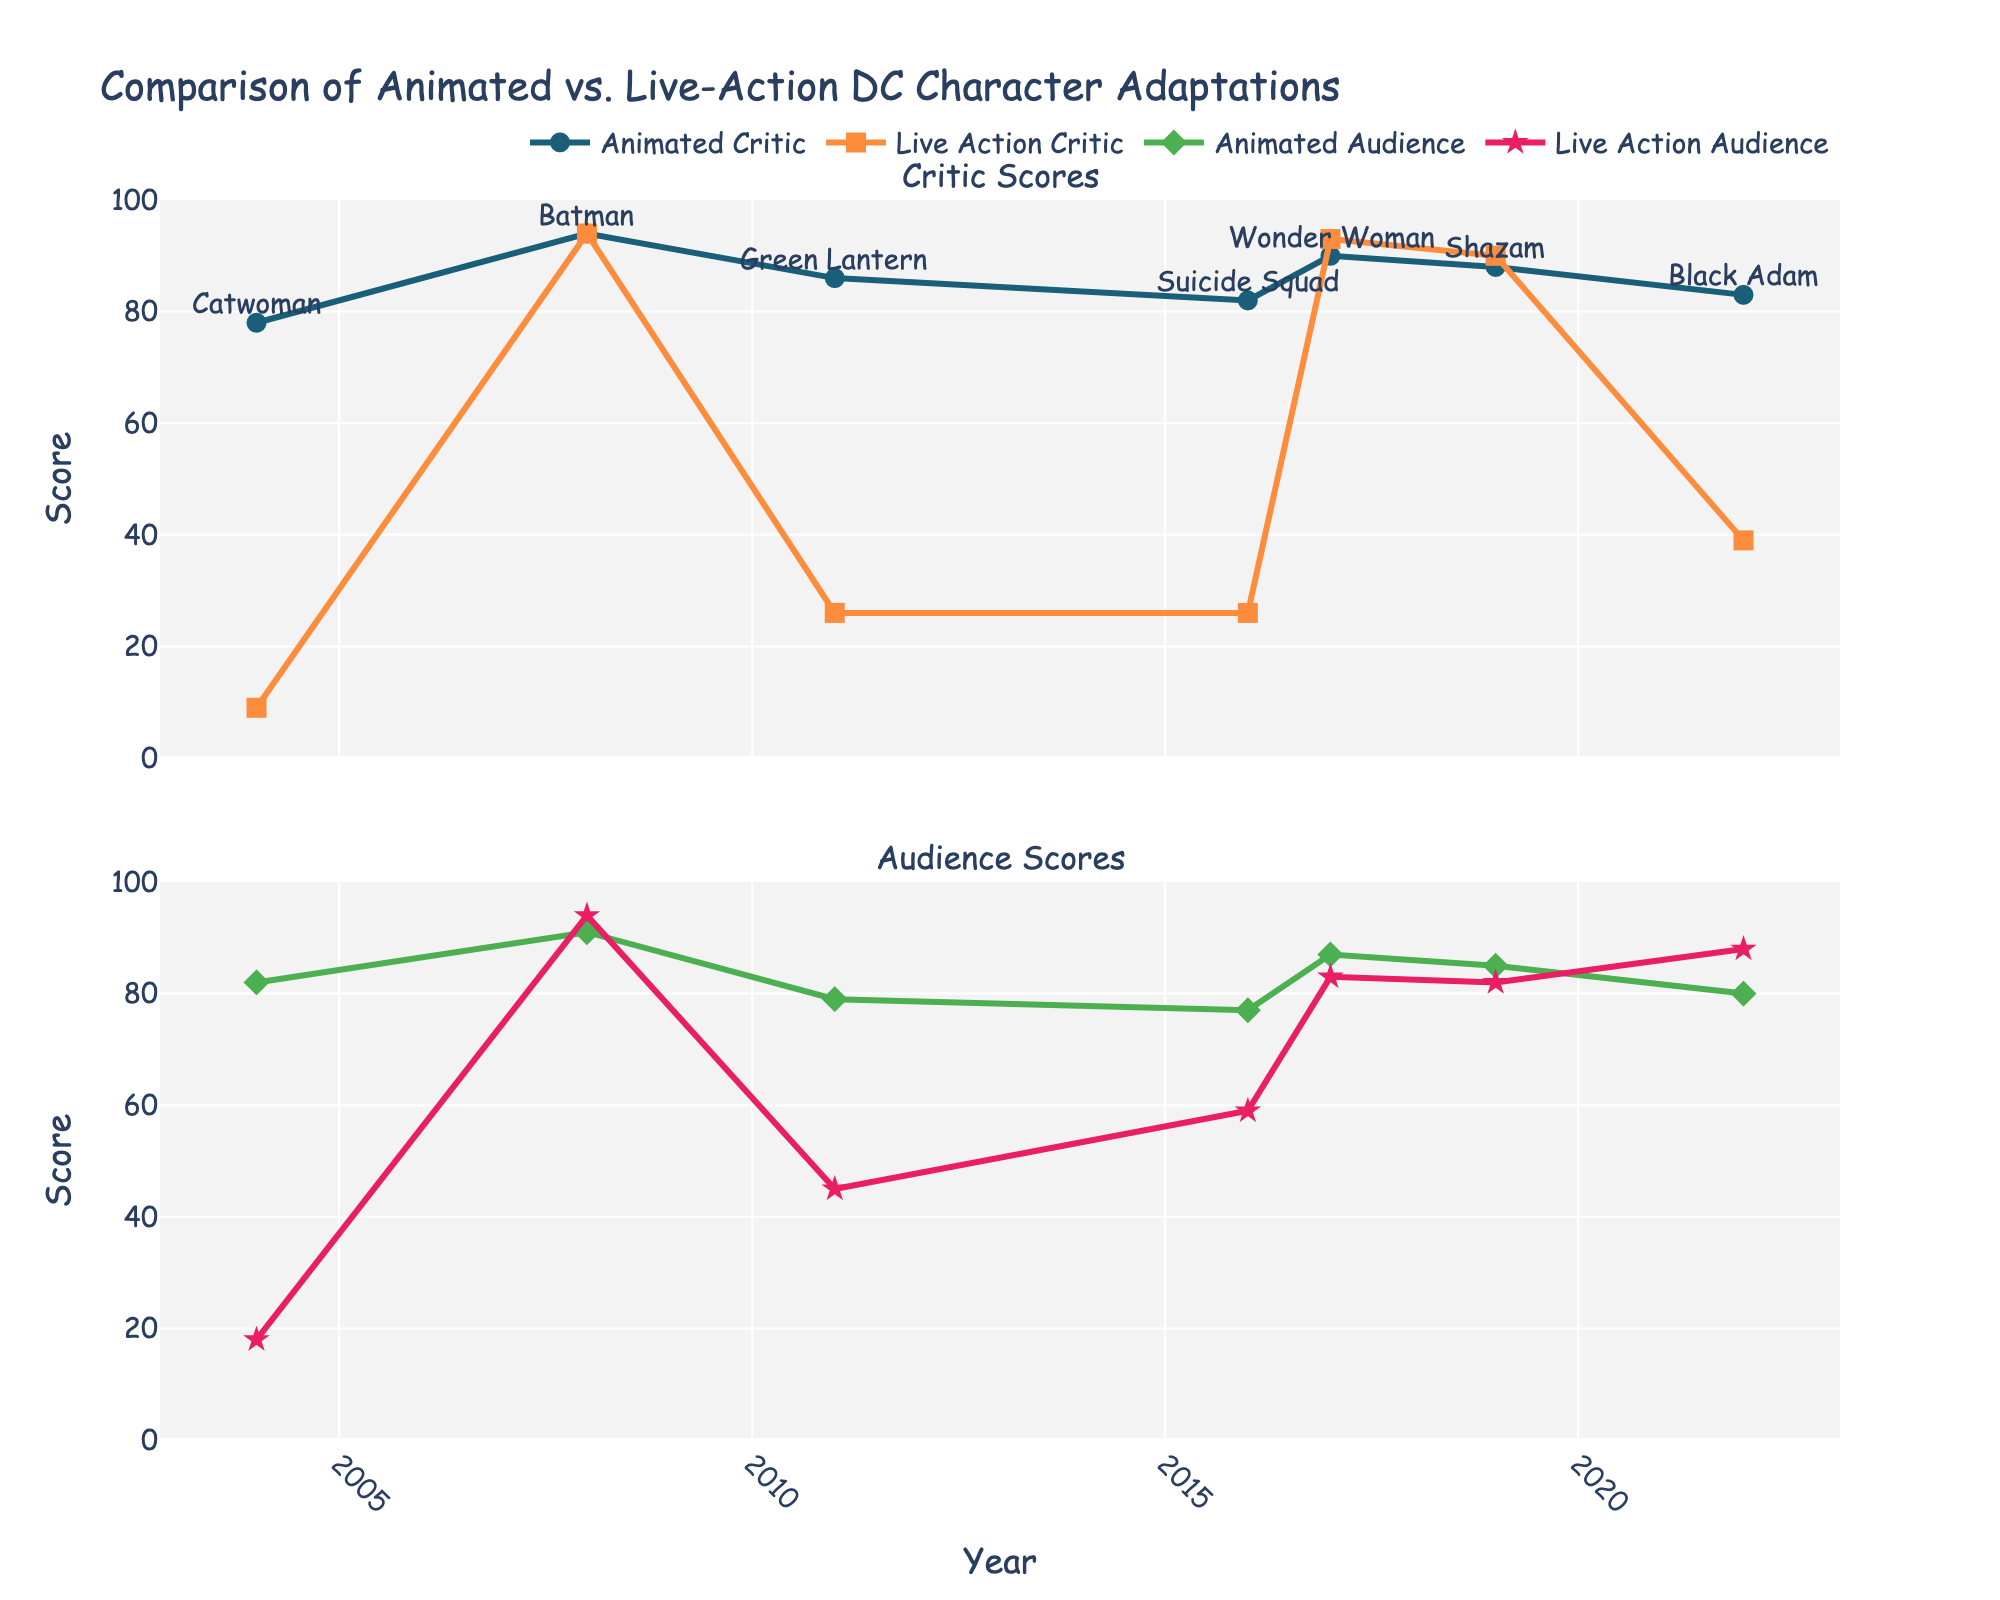What is the title of the figure? The title is located at the top of the figure. It helps in understanding the overall subject of the figure, which is a comparison of animated vs. live-action DC character adaptations.
Answer: Comparison of Animated vs. Live-Action DC Character Adaptations Which year shows the largest discrepancy in critic scores between animated and live-action adaptations? Identify the critic scores for both animated and live-action adaptations across all years and find the year where the difference between the two is the largest.
Answer: 2004 What is the average critic score for animated adaptations? Sum all the critic scores for animated adaptations and divide by the number of data points to find the average. The data points are (78, 94, 86, 82, 90, 88, 83).
Answer: 86.7 Which character received the highest audience score for its live-action adaptation? Look at all the audience scores for live-action adaptations and find the highest one. Identify the character associated with this score.
Answer: Black Adam How do the critic scores for Batman compare between animated and live-action adaptations in 2008? Check the critic scores for Batman in 2008 for both animated and live-action. Compare the two values.
Answer: Both are 94 What is the difference in audience scores between Wonder Woman's animated and live-action adaptations in 2017? Subtract the audience score for Wonder Woman's animated adaptation from its live-action score for the year 2017.
Answer: 4 Which character has the smallest gap between critic and audience scores in its animated adaptation? Calculate the difference between critic and audience scores for each character's animated adaptation and find the smallest gap.
Answer: Shazam In which year did both animated and live-action adaptations have the highest critic scores simultaneously? Identify the years where critic scores for both animated and live-action were high, and check if they match the highest scores for both types simultaneously.
Answer: 2008 What trend can be observed in the audience scores for animated adaptations from 2004 to 2022? Look at how the audience scores for animated adaptations changed for each year from 2004 to 2022 and describe the trend.
Answer: Generally stable with slight fluctuations How does the critic score trend for animated adaptations compare to that for live-action adaptations from 2004 to 2022? Observe the plot lines for both animated and live-action critic scores over the years and compare the general trends, identifying any notable differences or similarities.
Answer: Animated scores are consistently higher than live-action scores 